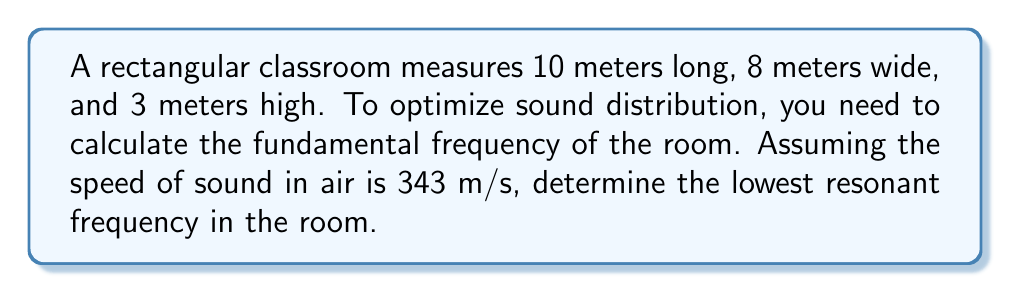Teach me how to tackle this problem. To solve this problem, we'll use the room acoustics equation for the fundamental frequency:

$$f = \frac{c}{2} \sqrt{\left(\frac{n_x}{L_x}\right)^2 + \left(\frac{n_y}{L_y}\right)^2 + \left(\frac{n_z}{L_z}\right)^2}$$

Where:
$f$ = fundamental frequency (Hz)
$c$ = speed of sound in air (343 m/s)
$L_x$, $L_y$, $L_z$ = room dimensions (m)
$n_x$, $n_y$, $n_z$ = mode numbers (use 1 for fundamental frequency)

Step 1: Insert the given values into the equation:
$$f = \frac{343}{2} \sqrt{\left(\frac{1}{10}\right)^2 + \left(\frac{1}{8}\right)^2 + \left(\frac{1}{3}\right)^2}$$

Step 2: Simplify the expression under the square root:
$$f = \frac{343}{2} \sqrt{0.01 + 0.015625 + 0.111111}$$
$$f = \frac{343}{2} \sqrt{0.136736}$$

Step 3: Calculate the square root:
$$f = \frac{343}{2} \cdot 0.369780$$

Step 4: Multiply:
$$f = 63.3651 \text{ Hz}$$

Step 5: Round to two decimal places:
$$f \approx 63.37 \text{ Hz}$$

This is the lowest resonant frequency in the classroom, which is crucial for optimal speaker placement and sound distribution.
Answer: 63.37 Hz 